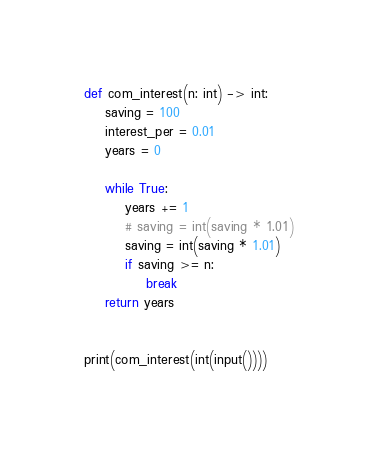<code> <loc_0><loc_0><loc_500><loc_500><_Python_>def com_interest(n: int) -> int:
    saving = 100
    interest_per = 0.01
    years = 0

    while True:
        years += 1
        # saving = int(saving * 1.01)
        saving = int(saving * 1.01)
        if saving >= n:
            break
    return years


print(com_interest(int(input())))</code> 